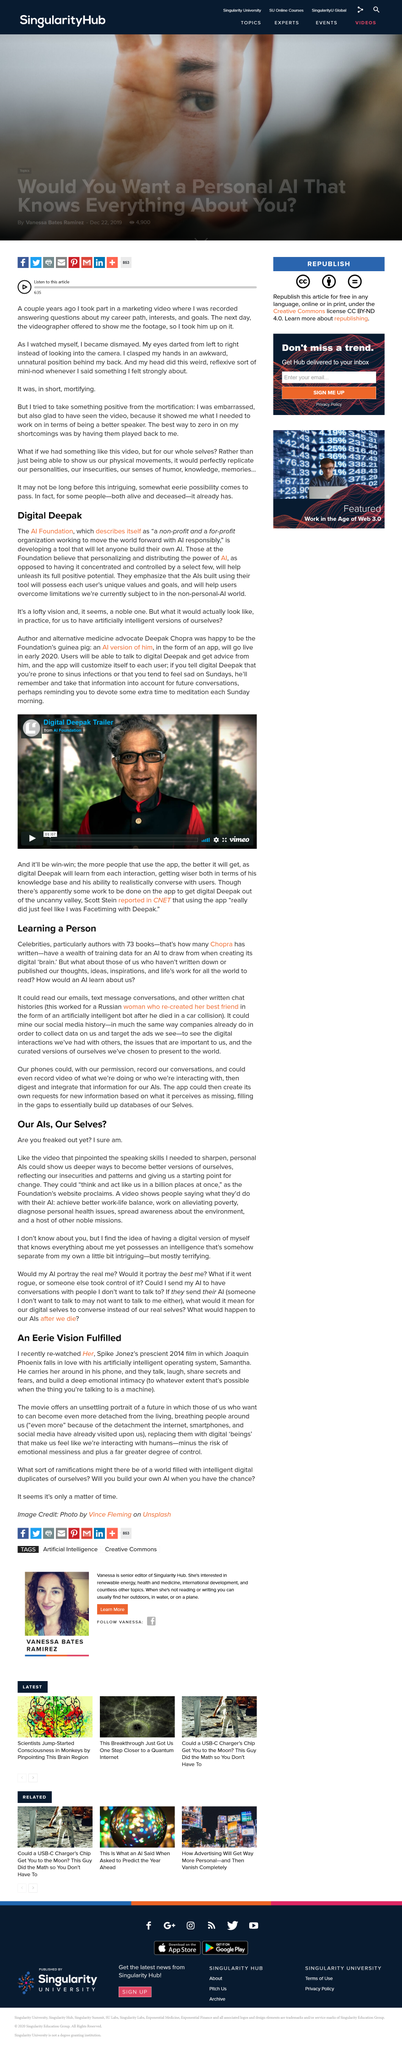Mention a couple of crucial points in this snapshot. The foundation's website declares that the AI could, "think and act like us in a billion places at once. According to individuals, they would utilize AI to achieve a better balance between work and personal life, address poverty, diagnose health issues, and raise awareness about environmental concerns. Spike Jonze directed the 2014 film "Her" in which the main character falls in love with an operating system. The movie portrays a dystopian future where people can replace living, breathing individuals with digital beings of their choice, leading to further detachment and a lack of empathy for real human connections. The AI Foundation Digital Deepak is a non-profit and for-profit organization dedicated to utilizing artificial intelligence in a responsible and ethical manner to improve society and drive progress forward. 